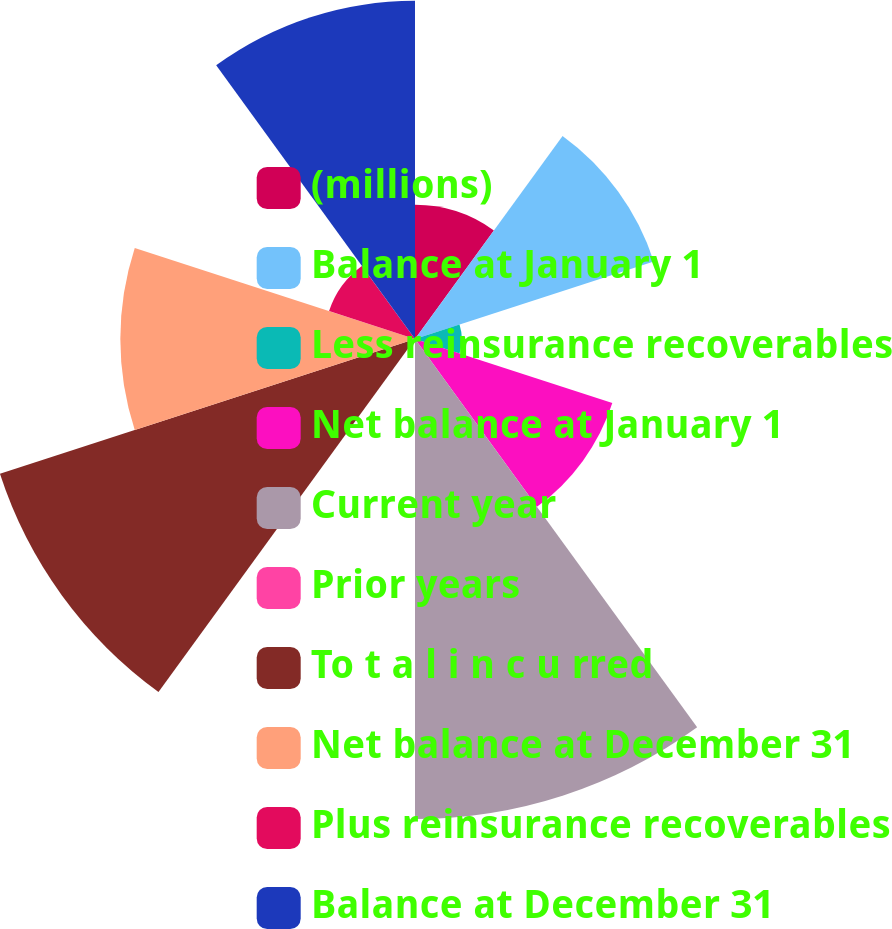Convert chart. <chart><loc_0><loc_0><loc_500><loc_500><pie_chart><fcel>(millions)<fcel>Balance at January 1<fcel>Less reinsurance recoverables<fcel>Net balance at January 1<fcel>Current year<fcel>Prior years<fcel>To t a l i n c u rred<fcel>Net balance at December 31<fcel>Plus reinsurance recoverables<fcel>Balance at December 31<nl><fcel>5.88%<fcel>11.0%<fcel>2.05%<fcel>9.09%<fcel>21.03%<fcel>0.14%<fcel>19.12%<fcel>12.91%<fcel>3.96%<fcel>14.82%<nl></chart> 